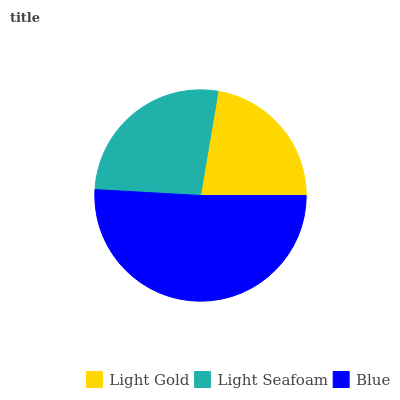Is Light Gold the minimum?
Answer yes or no. Yes. Is Blue the maximum?
Answer yes or no. Yes. Is Light Seafoam the minimum?
Answer yes or no. No. Is Light Seafoam the maximum?
Answer yes or no. No. Is Light Seafoam greater than Light Gold?
Answer yes or no. Yes. Is Light Gold less than Light Seafoam?
Answer yes or no. Yes. Is Light Gold greater than Light Seafoam?
Answer yes or no. No. Is Light Seafoam less than Light Gold?
Answer yes or no. No. Is Light Seafoam the high median?
Answer yes or no. Yes. Is Light Seafoam the low median?
Answer yes or no. Yes. Is Blue the high median?
Answer yes or no. No. Is Blue the low median?
Answer yes or no. No. 